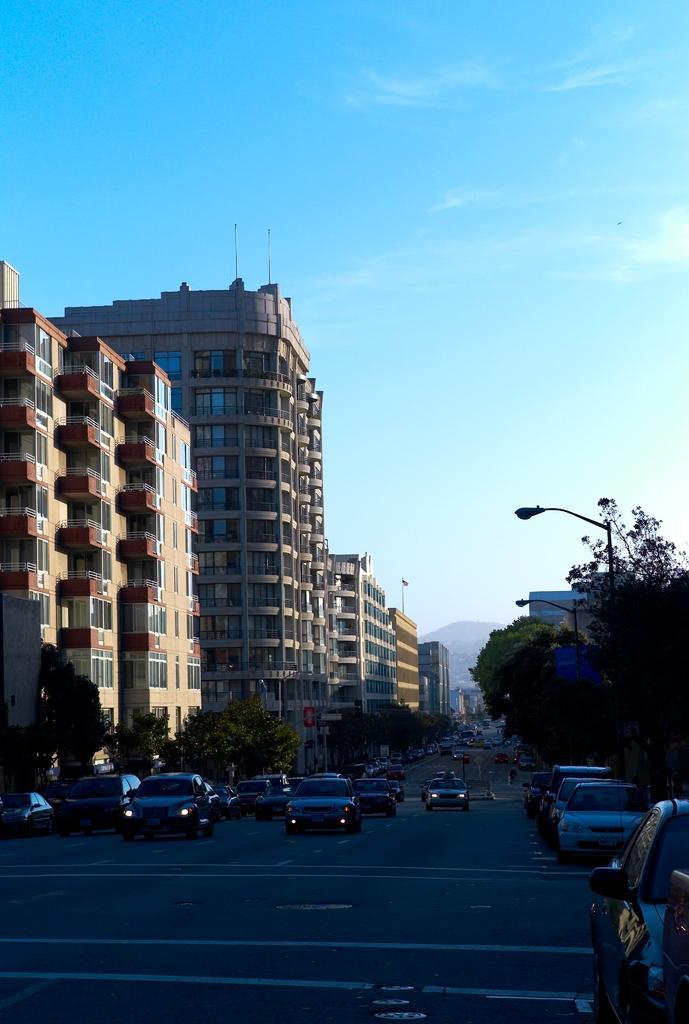In one or two sentences, can you explain what this image depicts? In this picture there are many cars moving on the road. On the left side there are some buildings and on the right corner we can see some tree and street pole. On the top there is a sky. 